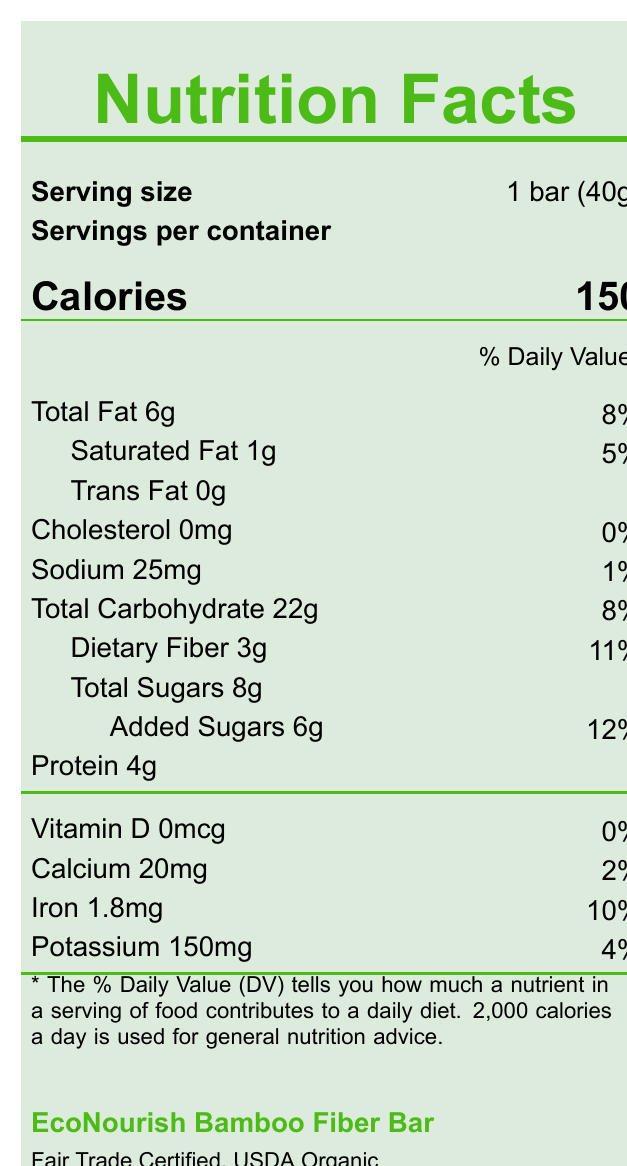what is the serving size for the snack bar? The serving size is indicated as "1 bar (40g)" on the label.
Answer: 1 bar (40g) how many calories are in one serving of the EcoNourish Bamboo Fiber Bar? The label shows "Calories 150", indicating there are 150 calories per serving.
Answer: 150 how much saturated fat is in the snack bar? The label specifies "Saturated Fat 1g".
Answer: 1g what percentage of the daily value is the sodium content? The label indicates "Sodium 25mg" with its daily value as "1%".
Answer: 1% what certification does the EcoNourish Bamboo Fiber Bar have? The label lists certifications as "Fair Trade Certified, USDA Organic".
Answer: Fair Trade Certified, USDA Organic which nutrient is found in the highest amount by weight in the EcoNourish Bamboo Fiber Bar? A. Protein B. Dietary Fiber C. Total Sugars D. Total Carbohydrate The document states "Total Carbohydrate 22g", which is the highest amount by weight.
Answer: D what is the main source of fiber in the EcoNourish Bamboo Fiber Bar? A. Organic dates B. Organic bamboo fiber C. Organic chia seeds D. Organic coconut oil The primary ingredient listed is "Organic bamboo fiber", which is known for its high fiber content.
Answer: B does the EcoNourish Bamboo Fiber Bar contain any trans fat? The label shows "Trans Fat 0g", indicating no trans fat.
Answer: No is the snack bar suitable for someone allergic to tree nuts? The allergen information states, "Contains tree nuts (cashews)", making it unsuitable for someone with tree nut allergies.
Answer: No summarize the main idea of the document. The document outlines the nutritional content, ingredients, allergen warnings, certifications, manufacturing location, and sustainability efforts for the EcoNourish Bamboo Fiber Bar, highlighting both its health benefits and ethical production practices.
Answer: The EcoNourish Bamboo Fiber Bar provides comprehensive nutritional information including serving size, calorie count, and detailed nutrient breakdown. It emphasizes its fair trade and organic certifications, sustainable packaging, and the manufacturer’s commitment to employee welfare. what is the amount of dietary fiber in the snack bar? The label states "Dietary Fiber 3g".
Answer: 3g how much protein does the snack bar contain? The label mentions "Protein 4g".
Answer: 4g what is the amount of added sugars in the snack bar? The label notes "Added Sugars 6g".
Answer: 6g what percentage of daily value does iron contribute? The label shows "Iron 1.8mg" with a daily value percentage of "10%".
Answer: 10% where is the manufacturing location of the EcoNourish Bamboo Fiber Bar? The label mentions "Manufacturing location: Surabaya, Indonesia".
Answer: Surabaya, Indonesia what does the sustainability note mention about the packaging and bamboo sourcing? The sustainability note specifies the eco-friendly aspects of the packaging and bamboo sourcing.
Answer: Packaging made from 100% recycled materials. Bamboo sourced from sustainable local farms. how many servings are there in a container of the EcoNourish Bamboo Fiber Bar? The label states "Servings per container: 1".
Answer: 1 what is the percentage daily value of calcium in the snack bar? The label indicates "Calcium 20mg" with a daily value percentage of "2%".
Answer: 2% can the exact number of calories from fat be determined from the information provided? The document provides the total calories and the amount of fat, but does not specify the exact calories derived from fat directly.
Answer: Cannot be determined 